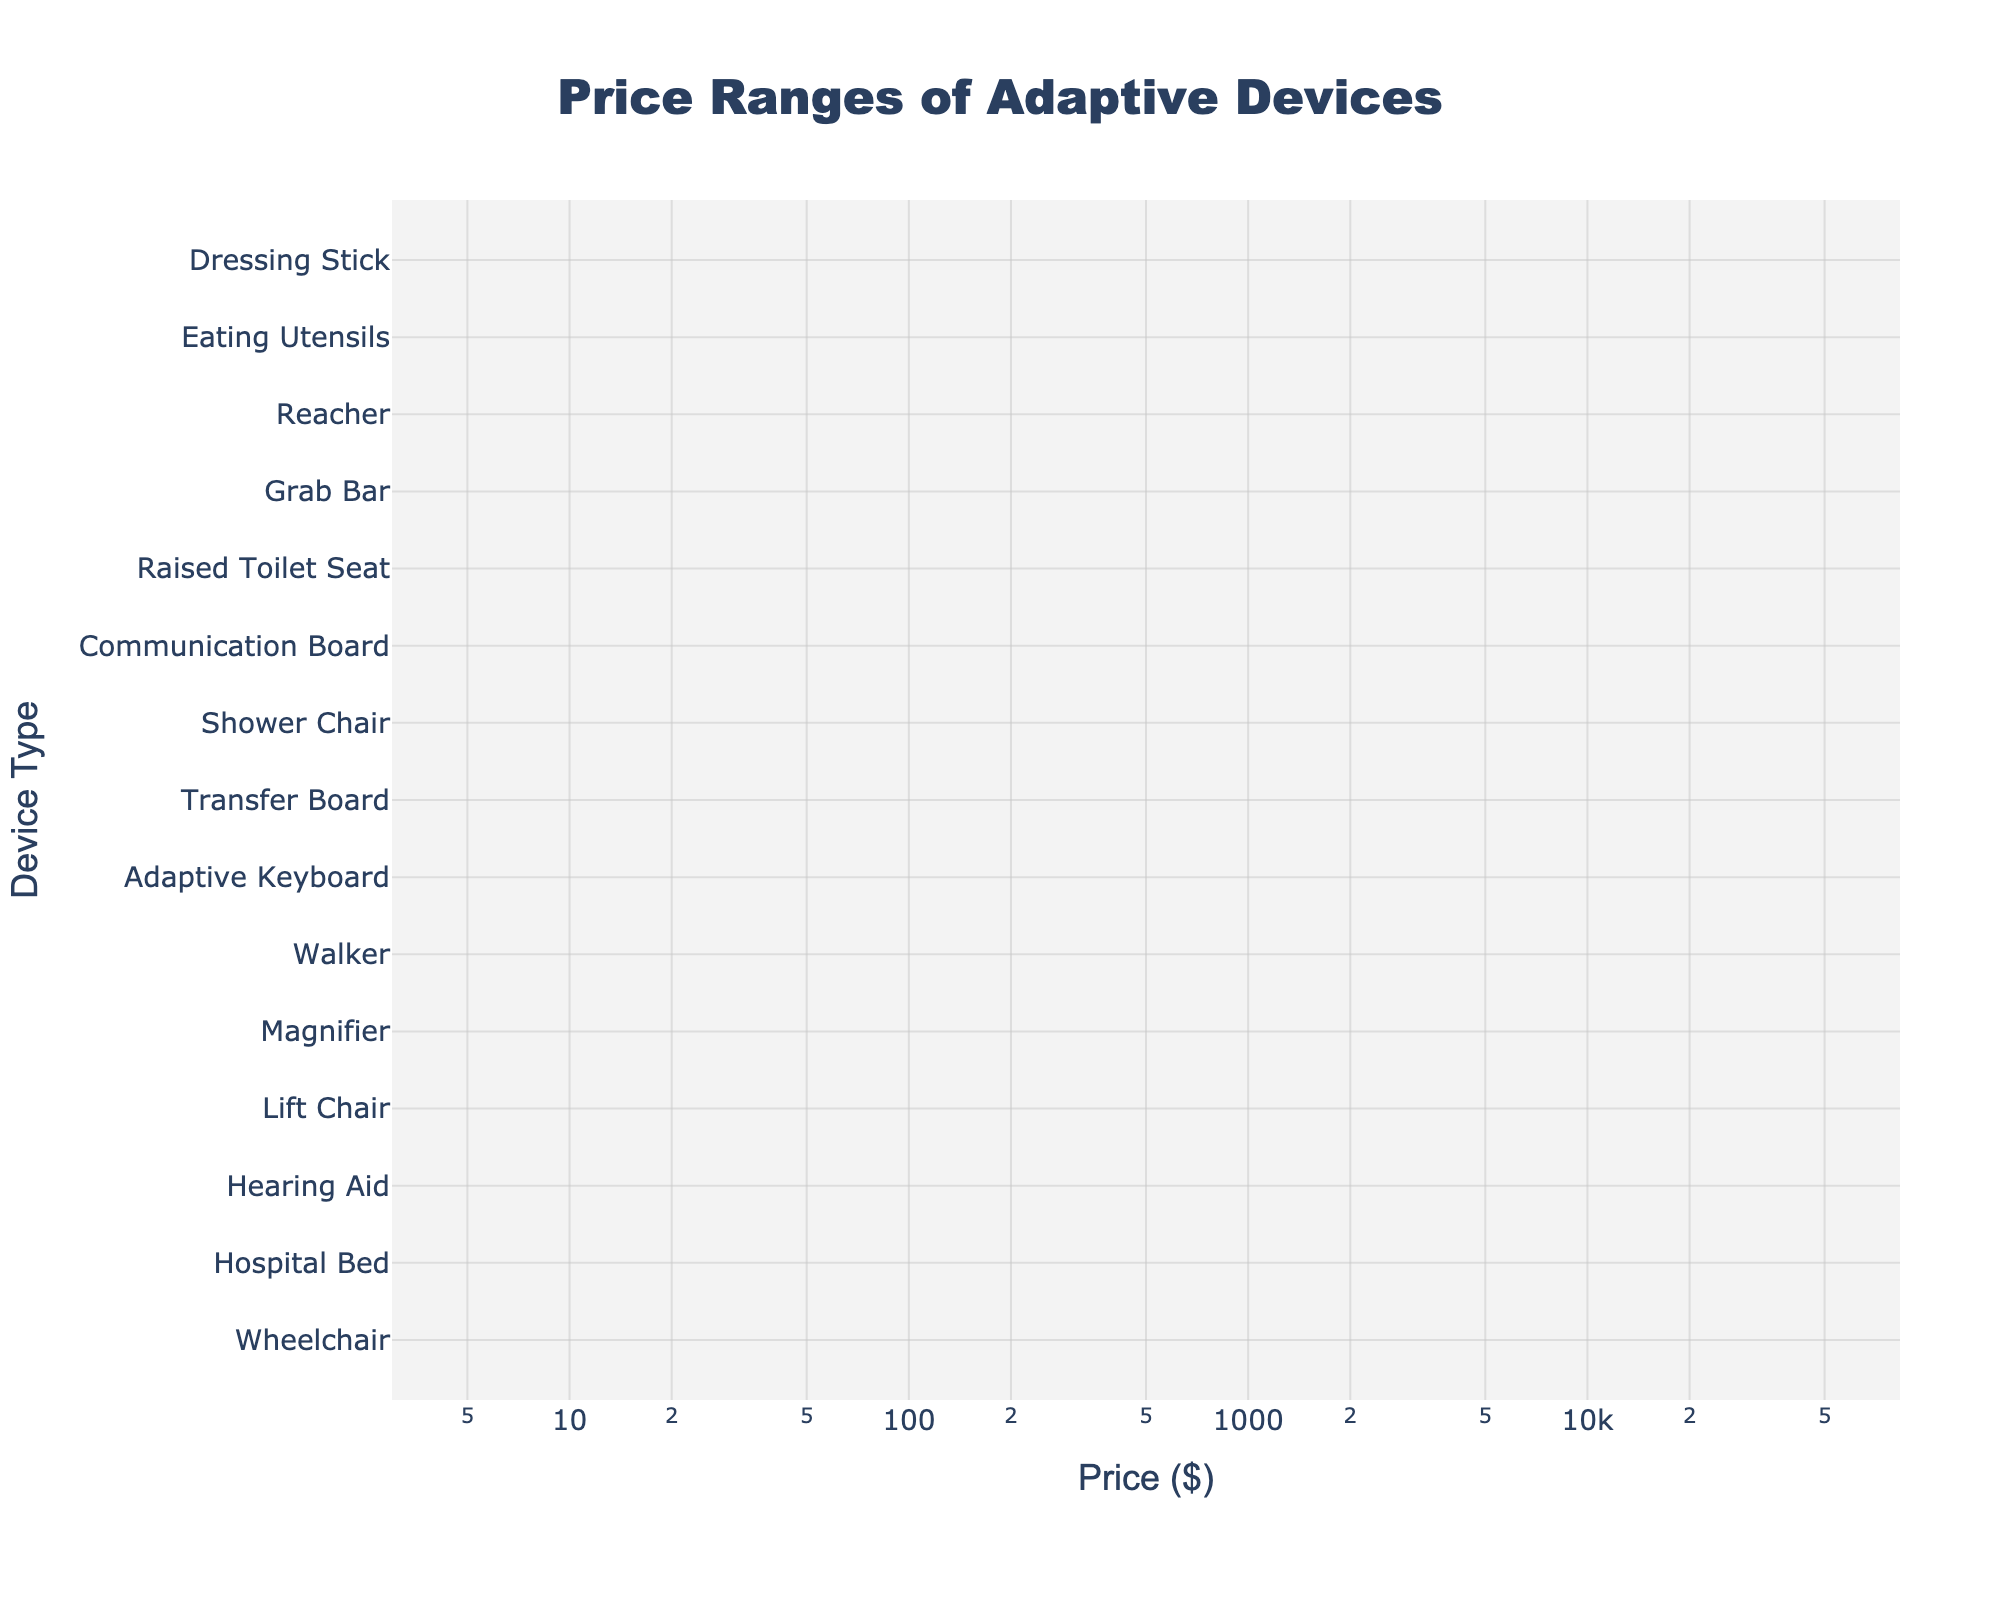what is the title of the plot? The title of the plot is found at the top of the figure, center-aligned, and it summarizes what the plot is showing. In this case, it reads 'Price Ranges of Adaptive Devices'.
Answer: Price Ranges of Adaptive Devices Which device type has the highest median price? The median price line for each device is represented by the horizontal position within the density plot. The device with the highest median price will be the one positioned furthest to the right. In this case, it is the 'Wheelchair'.
Answer: Wheelchair What is the range of prices for 'Grab Bar'? By locating 'Grab Bar' along the y-axis, then observing the violin plot’s horizontal spread, the endpoints indicate the price range. For 'Grab Bar', the range is between $20 and $150.
Answer: 20-150 Which device type falls within the price range of $50 to $300? By analyzing the horizontal spread of the density plots and checking which ones lie between $50 and $300, we can identify devices fitting this range. 'Walker', 'Adaptive Keyboard', and 'Transfer Board' fall within this price range.
Answer: Walker, Adaptive Keyboard, Transfer Board How does the price range of 'Hospital Bed' compare to 'Lift Chair'? By comparing the horizontal extents of the 'Hospital Bed' and 'Lift Chair' plots on the x-axis, we can see that the price ranges for 'Hospital Bed' are from $500 to $3000, whereas 'Lift Chair' ranges from $400 to $2000. The 'Hospital Bed' has a higher maximum price.
Answer: Hospital Bed has a higher maximum price Which device for bathing has the lowest price range? Locate the devices related to bathing, then compare their price ranges. In this case, the device is 'Shower Chair' which ranges from $30 to $200. 'Shower Chair' is the only one listed under the 'Bathing' functional need.
Answer: Shower Chair What's the median price of the 'Hearing Aid'? Find the horizontal center of the violin plot corresponding to the 'Hearing Aid'. This value represents the median price. Given the range of $500 to $3000, the median price is $(500+3000)/2 = $1750.
Answer: $1750 Between 'Raised Toilet Seat' and 'Adaptive Keyboard', which one has the wider price range? Compare the width of the density plots of 'Raised Toilet Seat' and 'Adaptive Keyboard' by looking at their horizontal spans. 'Raised Toilet Seat' ranges from $25 to $150, whereas 'Adaptive Keyboard' ranges from $50 to $300; thus, ‘Adaptive Keyboard’ has the wider range of $50 to $300.
Answer: Adaptive Keyboard Arrange the 'Mobility' related devices from highest to lowest based on their maximum price. Identify the devices labeled as 'Mobility' and note their maximum prices. 'Wheelchair' (5000), 'Walker' (300). Therefore, the order is 'Wheelchair', 'Walker'.
Answer: Wheelchair, Walker Which functional need has the most diverse range of device prices? By identifying the range of prices for each functional need, 'Mobility' stands out for having both the 'Wheelchair' (span: $4500) with one of the widest ranges and 'Walker' with a narrower but diverse span compared to other needs.
Answer: Mobility 